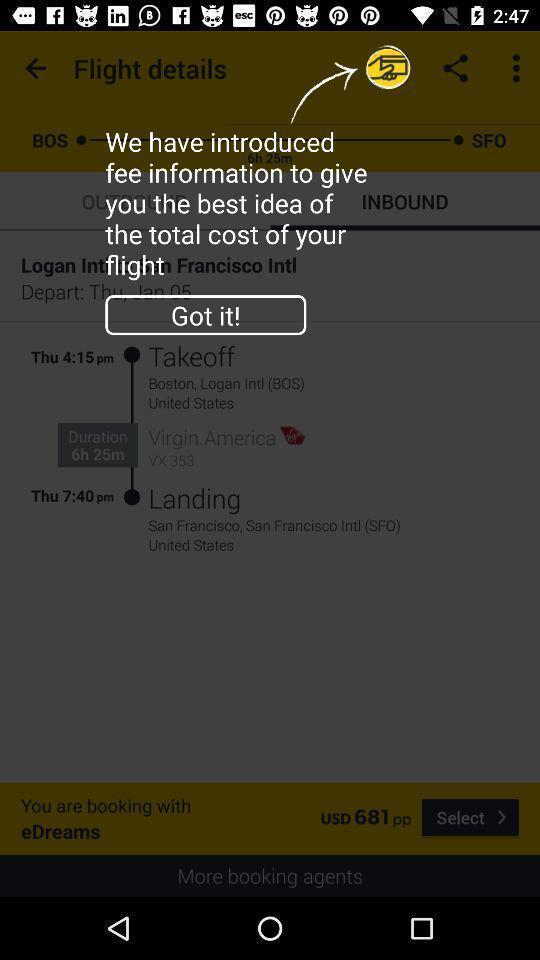Give me a summary of this screen capture. Pop-up displaying the new feature update. 